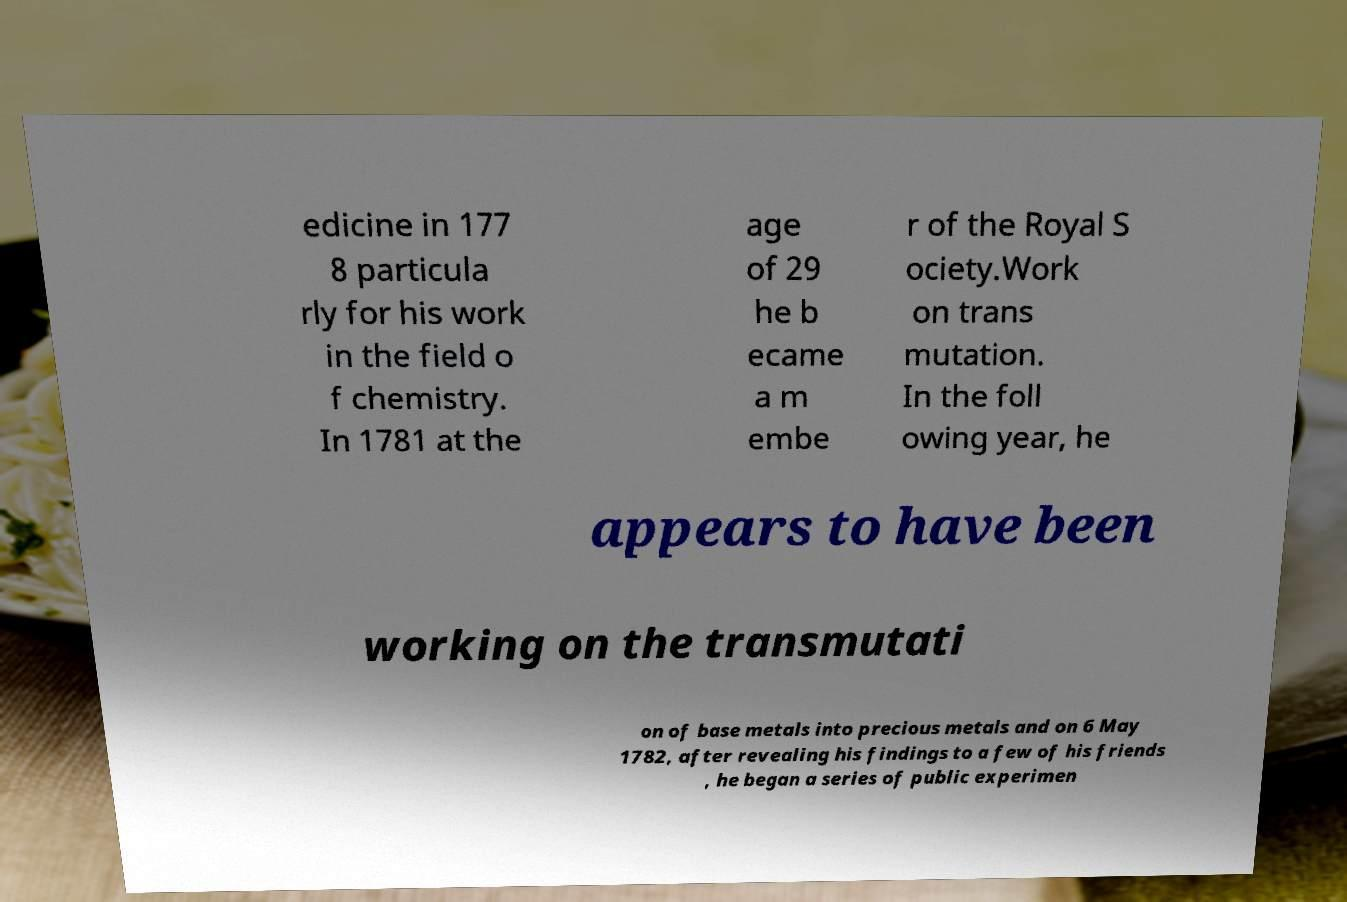Could you assist in decoding the text presented in this image and type it out clearly? edicine in 177 8 particula rly for his work in the field o f chemistry. In 1781 at the age of 29 he b ecame a m embe r of the Royal S ociety.Work on trans mutation. In the foll owing year, he appears to have been working on the transmutati on of base metals into precious metals and on 6 May 1782, after revealing his findings to a few of his friends , he began a series of public experimen 